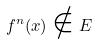<formula> <loc_0><loc_0><loc_500><loc_500>f ^ { n } ( x ) \notin E</formula> 